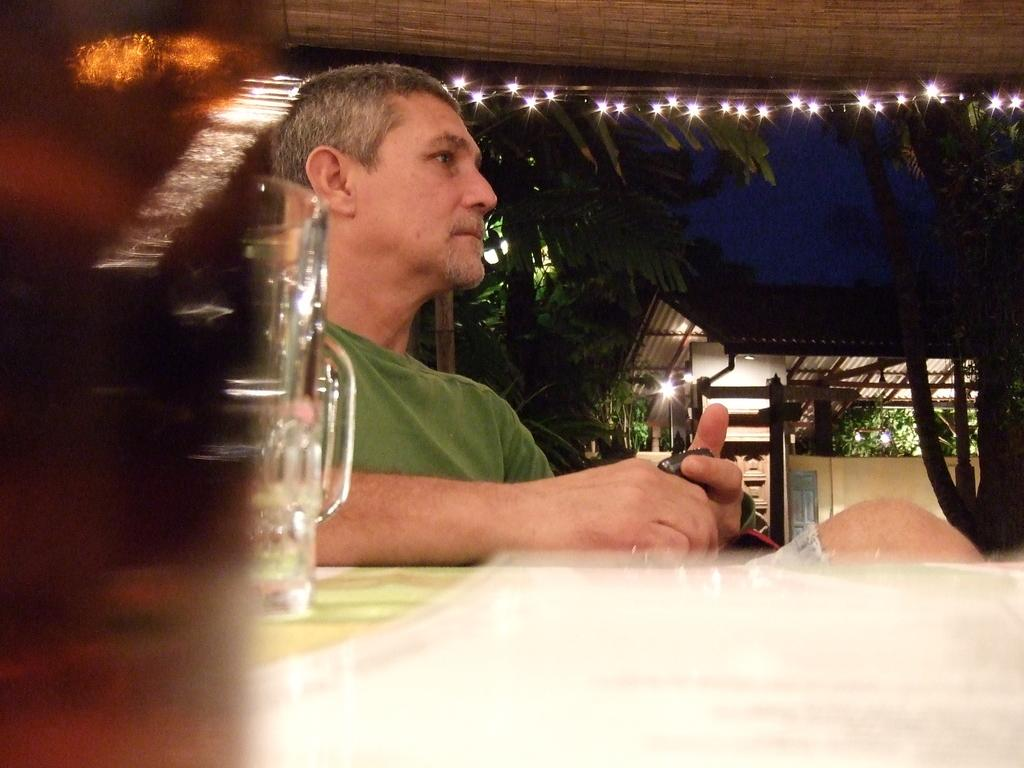Who is present in the image? There is a man in the picture. What is the man doing in the image? The man is standing in front of a table. What is the man wearing in the image? The man is wearing a green T-shirt. What object can be seen on the table in the image? There is a glass placed on the table. What can be seen in the background of the image? There are trees and lights in the background of the image. What type of camp can be seen in the aftermath of the image? There is no camp or aftermath present in the image; it features a man standing in front of a table with a glass on it, and trees and lights in the background. 